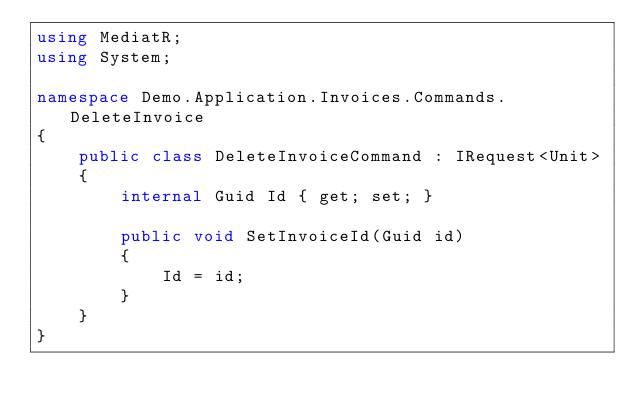Convert code to text. <code><loc_0><loc_0><loc_500><loc_500><_C#_>using MediatR;
using System;

namespace Demo.Application.Invoices.Commands.DeleteInvoice
{
    public class DeleteInvoiceCommand : IRequest<Unit>
    {
        internal Guid Id { get; set; }

        public void SetInvoiceId(Guid id)
        {
            Id = id;
        }
    }
}</code> 